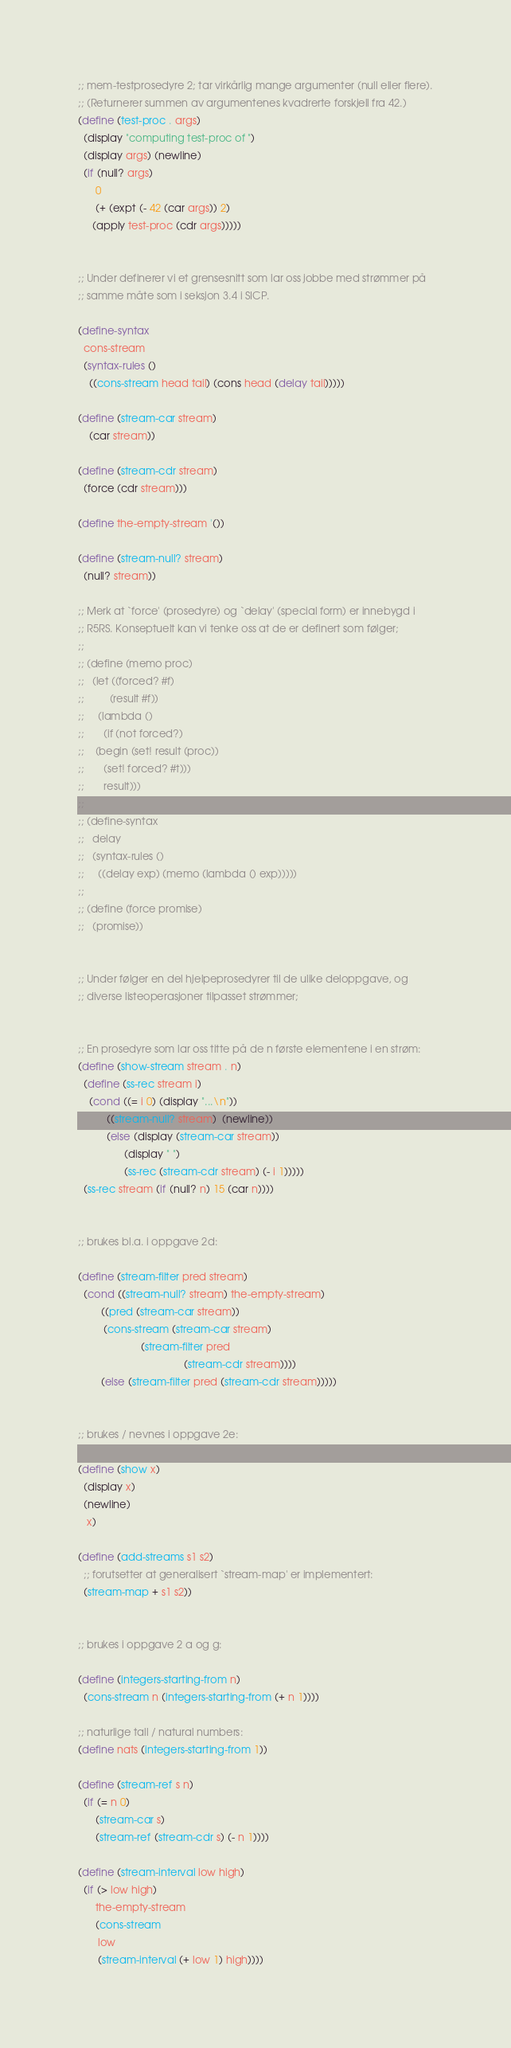<code> <loc_0><loc_0><loc_500><loc_500><_Scheme_>

;; mem-testprosedyre 2; tar virkårlig mange argumenter (null eller flere).
;; (Returnerer summen av argumentenes kvadrerte forskjell fra 42.)
(define (test-proc . args)
  (display "computing test-proc of ")
  (display args) (newline)
  (if (null? args)
      0
      (+ (expt (- 42 (car args)) 2)
	 (apply test-proc (cdr args)))))


;; Under definerer vi et grensesnitt som lar oss jobbe med strømmer på
;; samme måte som i seksjon 3.4 i SICP.

(define-syntax
  cons-stream
  (syntax-rules ()
    ((cons-stream head tail) (cons head (delay tail)))))

(define (stream-car stream) 
    (car stream))

(define (stream-cdr stream) 
  (force (cdr stream)))

(define the-empty-stream '())

(define (stream-null? stream) 
  (null? stream))

;; Merk at `force' (prosedyre) og `delay' (special form) er innebygd i
;; R5RS. Konseptuelt kan vi tenke oss at de er definert som følger;
;;
;; (define (memo proc)
;;   (let ((forced? #f) 
;;         (result #f))
;;     (lambda ()
;;       (if (not forced?)
;; 	  (begin (set! result (proc))
;; 		 (set! forced? #t)))
;;       result)))
;;
;; (define-syntax
;;   delay
;;   (syntax-rules ()
;;     ((delay exp) (memo (lambda () exp)))))
;;
;; (define (force promise)
;;   (promise))


;; Under følger en del hjelpeprosedyrer til de ulike deloppgave, og
;; diverse listeoperasjoner tilpasset strømmer;


;; En prosedyre som lar oss titte på de n første elementene i en strøm:
(define (show-stream stream . n)
  (define (ss-rec stream i)
    (cond ((= i 0) (display "...\n"))
          ((stream-null? stream)  (newline))
          (else (display (stream-car stream))
                (display " ")
                (ss-rec (stream-cdr stream) (- i 1)))))
  (ss-rec stream (if (null? n) 15 (car n))))


;; brukes bl.a. i oppgave 2d:

(define (stream-filter pred stream)
  (cond ((stream-null? stream) the-empty-stream)
        ((pred (stream-car stream))
         (cons-stream (stream-car stream)
                      (stream-filter pred
                                     (stream-cdr stream))))
        (else (stream-filter pred (stream-cdr stream)))))


;; brukes / nevnes i oppgave 2e:

(define (show x) 
  (display x)
  (newline)
   x)

(define (add-streams s1 s2)
  ;; forutsetter at generalisert `stream-map' er implementert:
  (stream-map + s1 s2))


;; brukes i oppgave 2 a og g:

(define (integers-starting-from n)
  (cons-stream n (integers-starting-from (+ n 1))))

;; naturlige tall / natural numbers:
(define nats (integers-starting-from 1))

(define (stream-ref s n)
  (if (= n 0)
      (stream-car s)
      (stream-ref (stream-cdr s) (- n 1))))

(define (stream-interval low high)
  (if (> low high)
      the-empty-stream
      (cons-stream
       low
       (stream-interval (+ low 1) high))))
</code> 